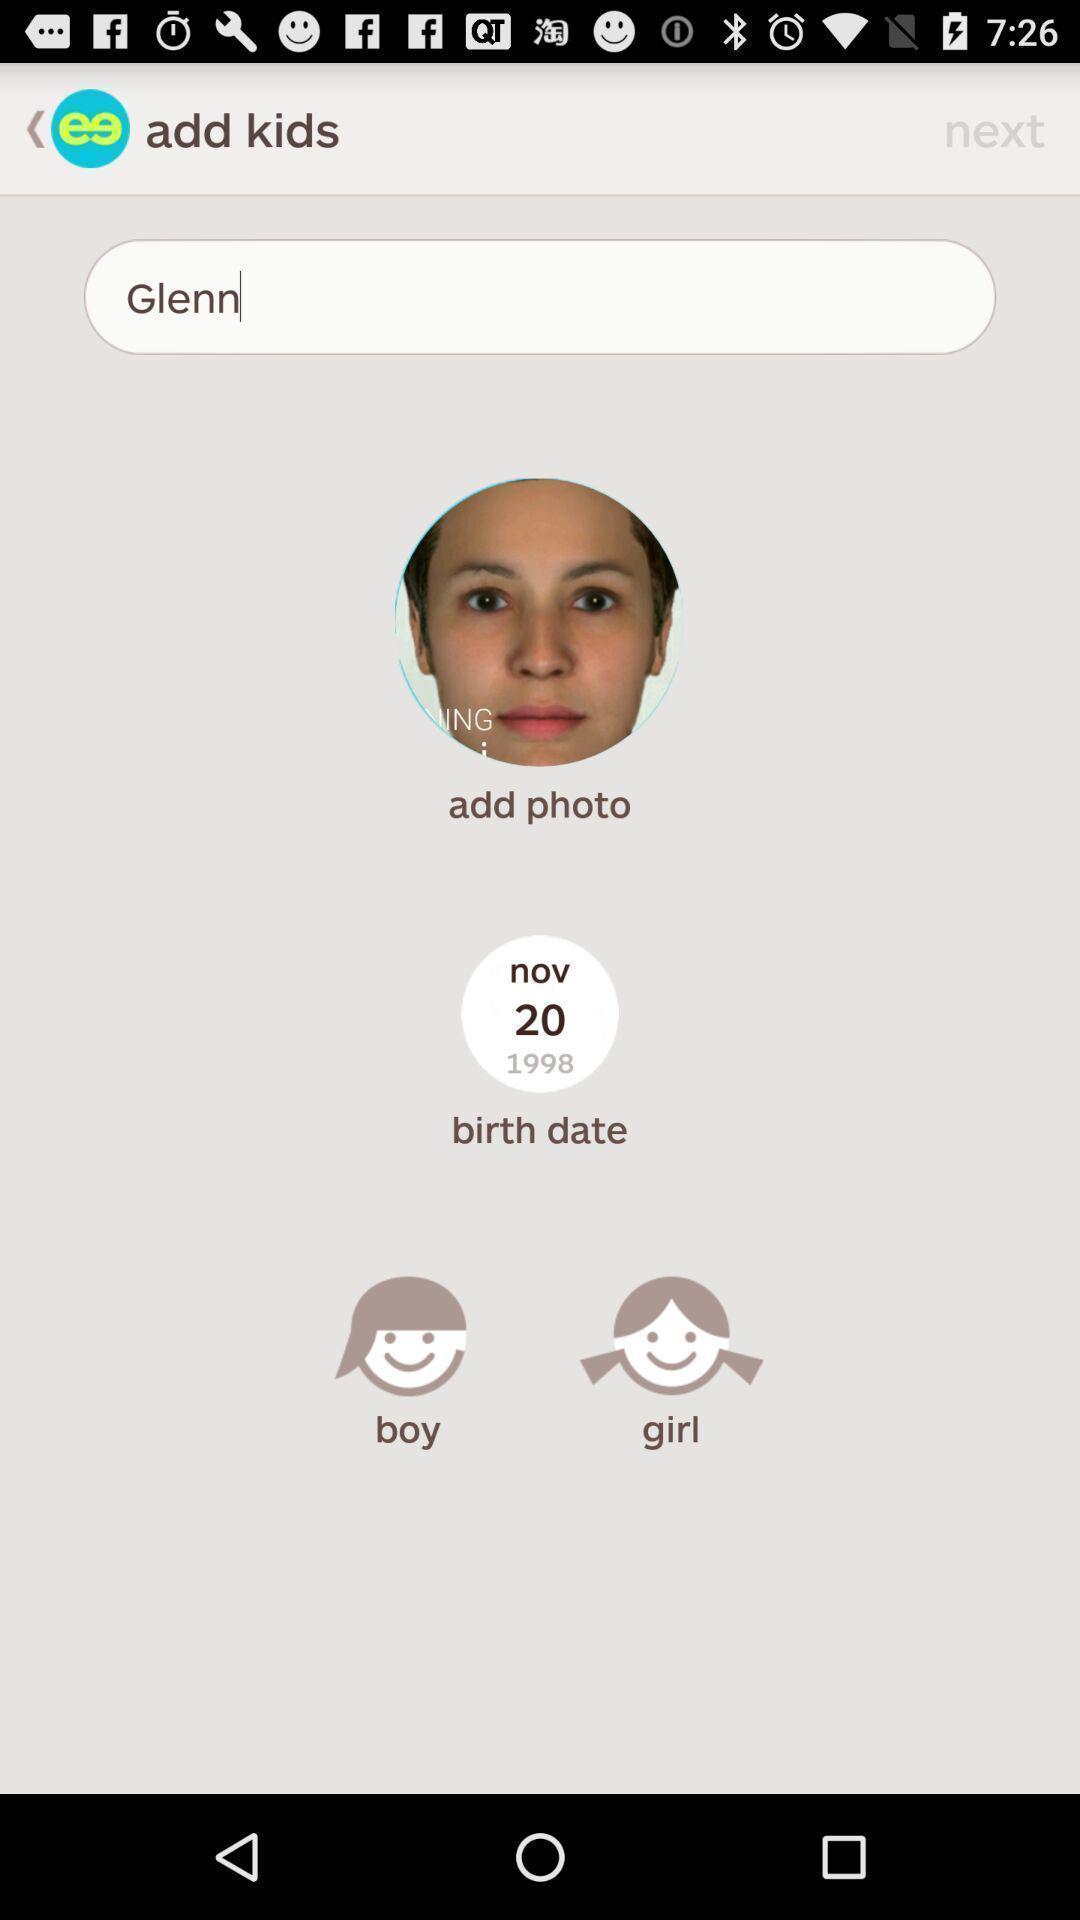Give me a narrative description of this picture. Page showing search bar to find people. 